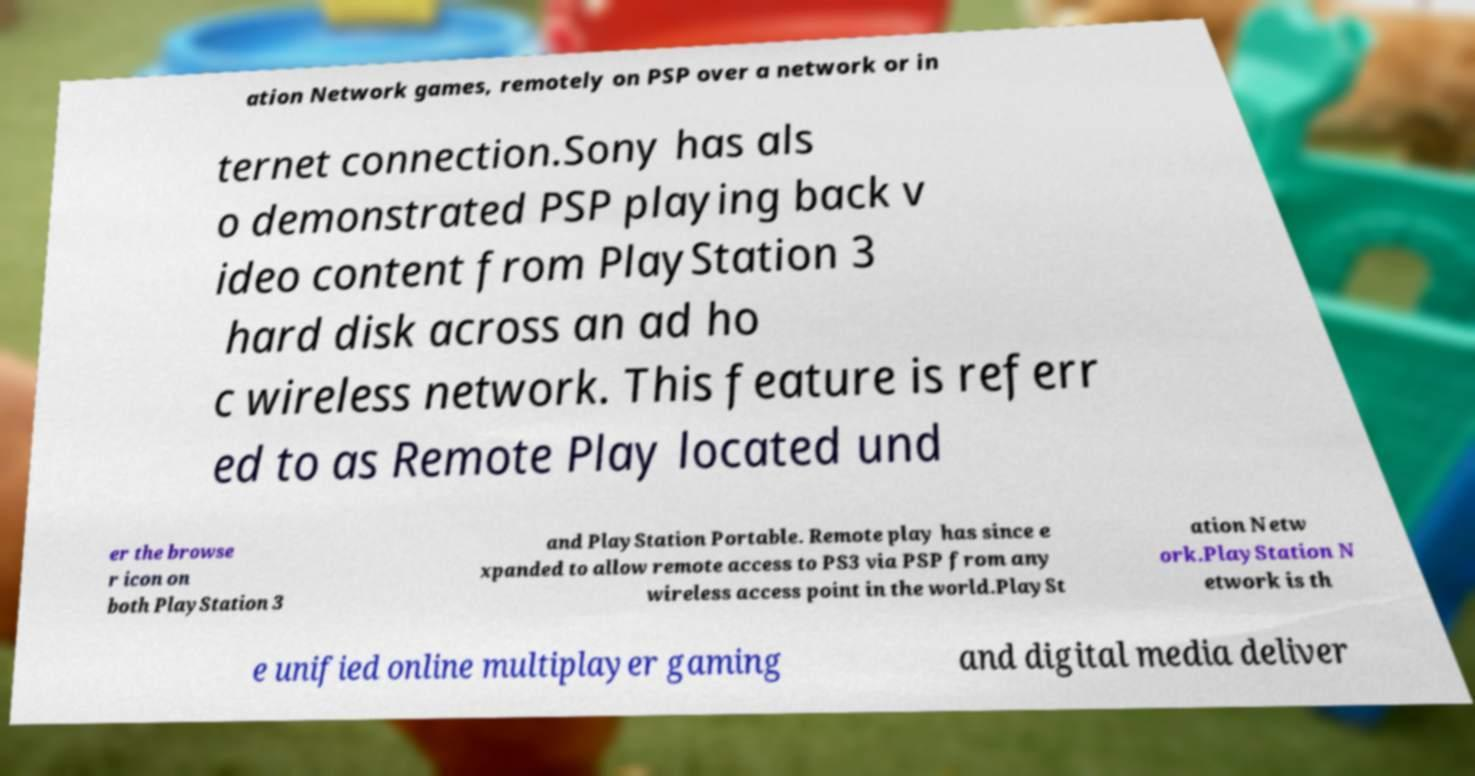I need the written content from this picture converted into text. Can you do that? ation Network games, remotely on PSP over a network or in ternet connection.Sony has als o demonstrated PSP playing back v ideo content from PlayStation 3 hard disk across an ad ho c wireless network. This feature is referr ed to as Remote Play located und er the browse r icon on both PlayStation 3 and PlayStation Portable. Remote play has since e xpanded to allow remote access to PS3 via PSP from any wireless access point in the world.PlaySt ation Netw ork.PlayStation N etwork is th e unified online multiplayer gaming and digital media deliver 